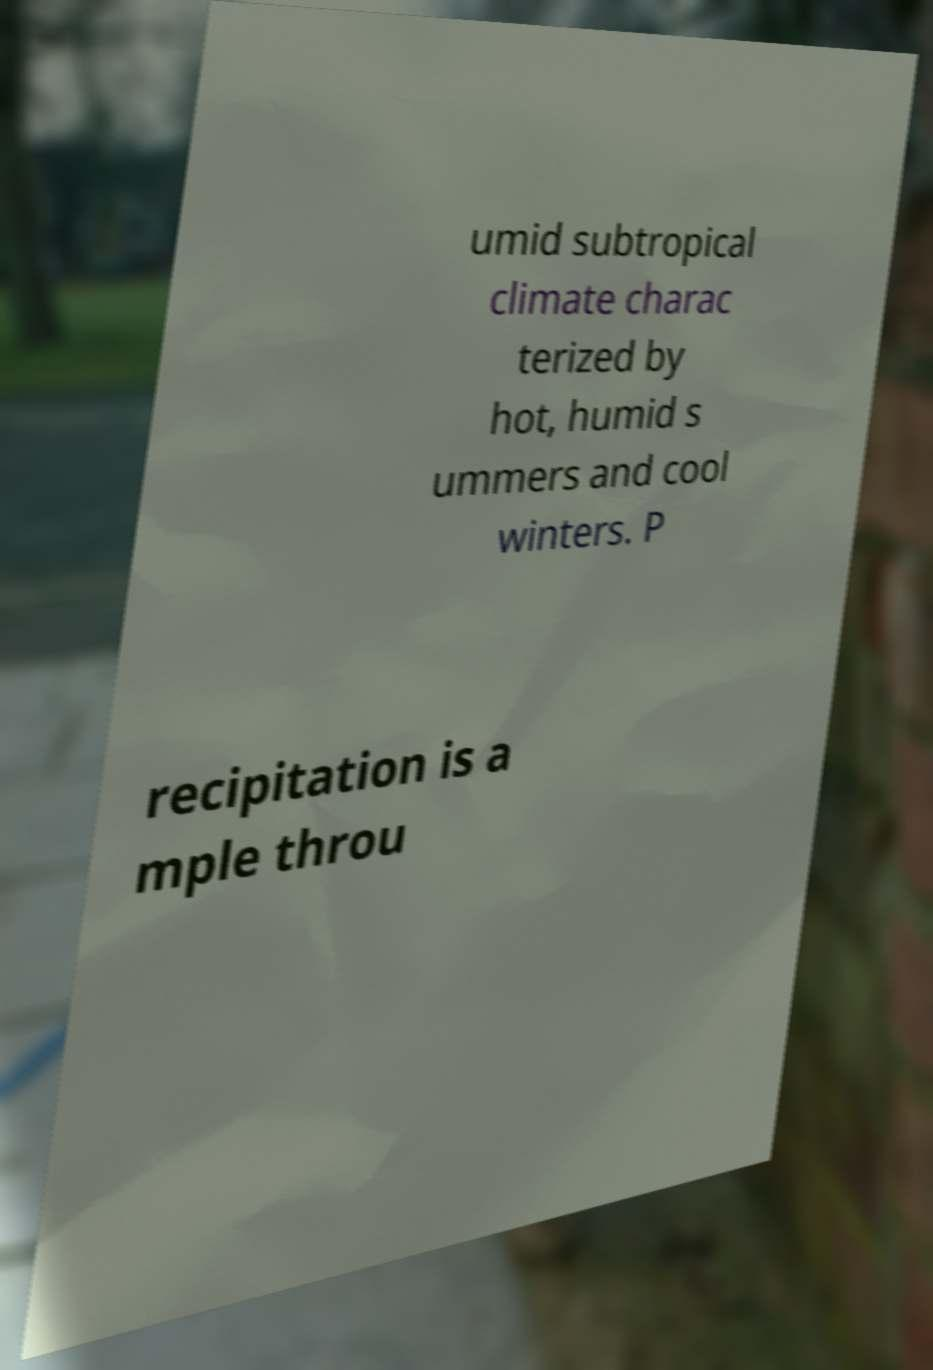Can you accurately transcribe the text from the provided image for me? umid subtropical climate charac terized by hot, humid s ummers and cool winters. P recipitation is a mple throu 